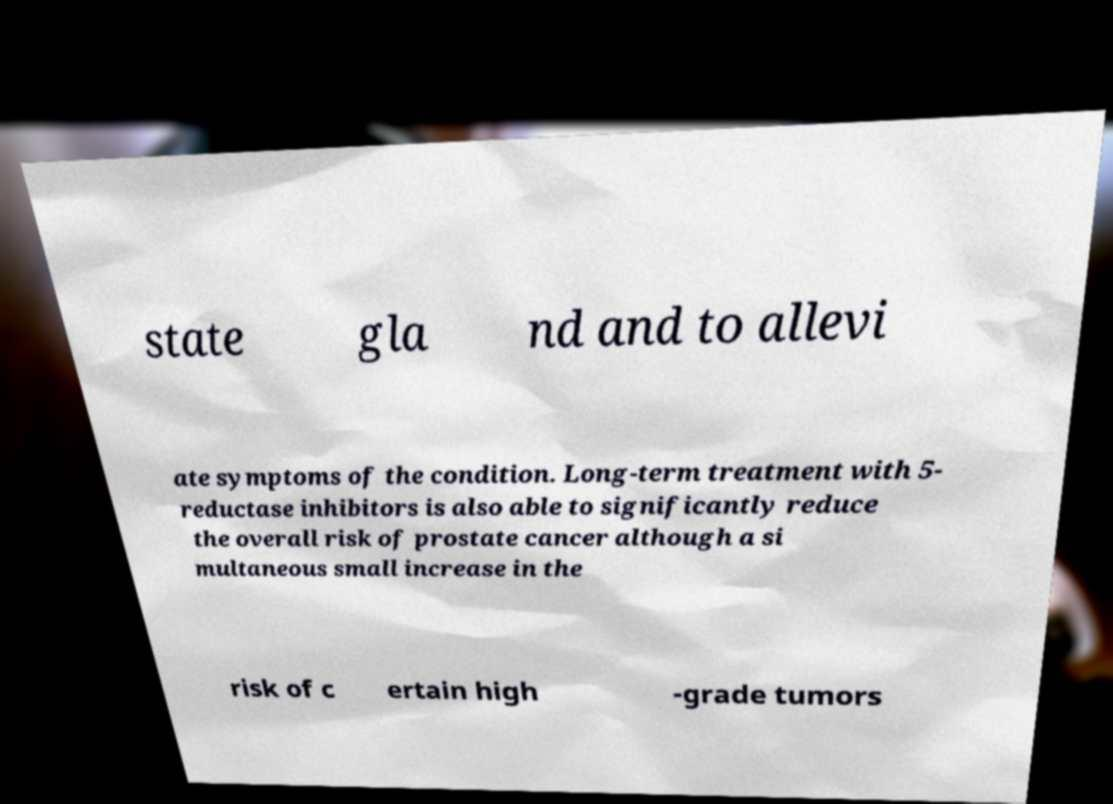There's text embedded in this image that I need extracted. Can you transcribe it verbatim? state gla nd and to allevi ate symptoms of the condition. Long-term treatment with 5- reductase inhibitors is also able to significantly reduce the overall risk of prostate cancer although a si multaneous small increase in the risk of c ertain high -grade tumors 